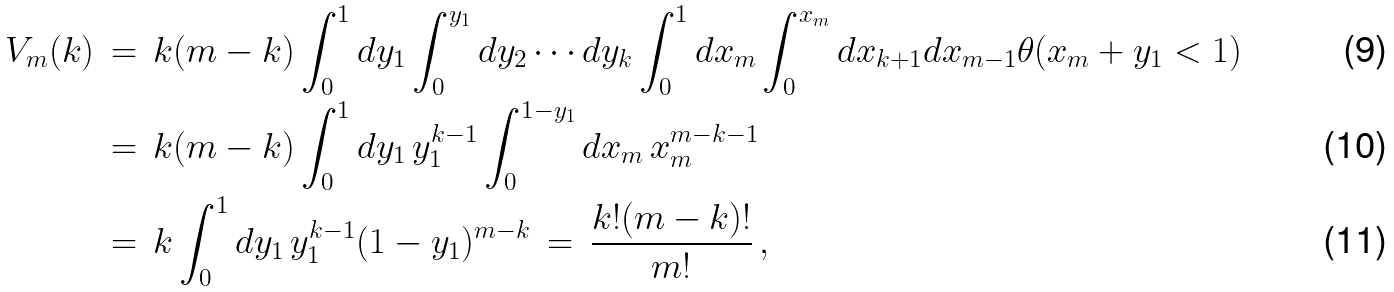<formula> <loc_0><loc_0><loc_500><loc_500>V _ { m } ( k ) \, & = \, k ( m - k ) \int _ { 0 } ^ { 1 } d y _ { 1 } \int _ { 0 } ^ { y _ { 1 } } d y _ { 2 } \cdots d y _ { k } \int _ { 0 } ^ { 1 } d x _ { m } \int _ { 0 } ^ { x _ { m } } d x _ { k + 1 } d x _ { m - 1 } \theta ( x _ { m } + y _ { 1 } < 1 ) \\ \, & = \, k ( m - k ) \int _ { 0 } ^ { 1 } d y _ { 1 } \, y _ { 1 } ^ { k - 1 } \int _ { 0 } ^ { 1 - y _ { 1 } } d x _ { m } \, x _ { m } ^ { m - k - 1 } \\ \, & = \, k \int _ { 0 } ^ { 1 } d y _ { 1 } \, y _ { 1 } ^ { k - 1 } ( 1 - y _ { 1 } ) ^ { m - k } \, = \, \frac { k ! ( m - k ) ! } { m ! } \, ,</formula> 